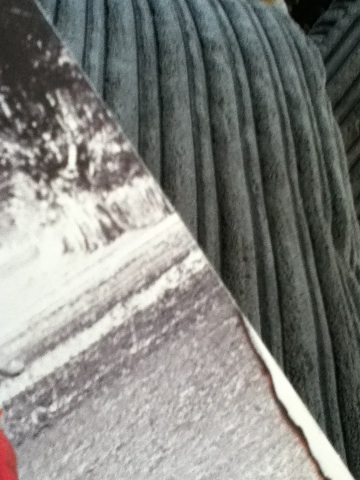What is this book called? Based on the visible portion of the image, it is not possible to determine the exact title of the book. However, it appears to be a paperback with a predominantly white and possibly textured cover that might indicate a specific genre or style. To provide a definitive answer, an image with a clearer view of the cover or spine where titles are typically located would be necessary. 